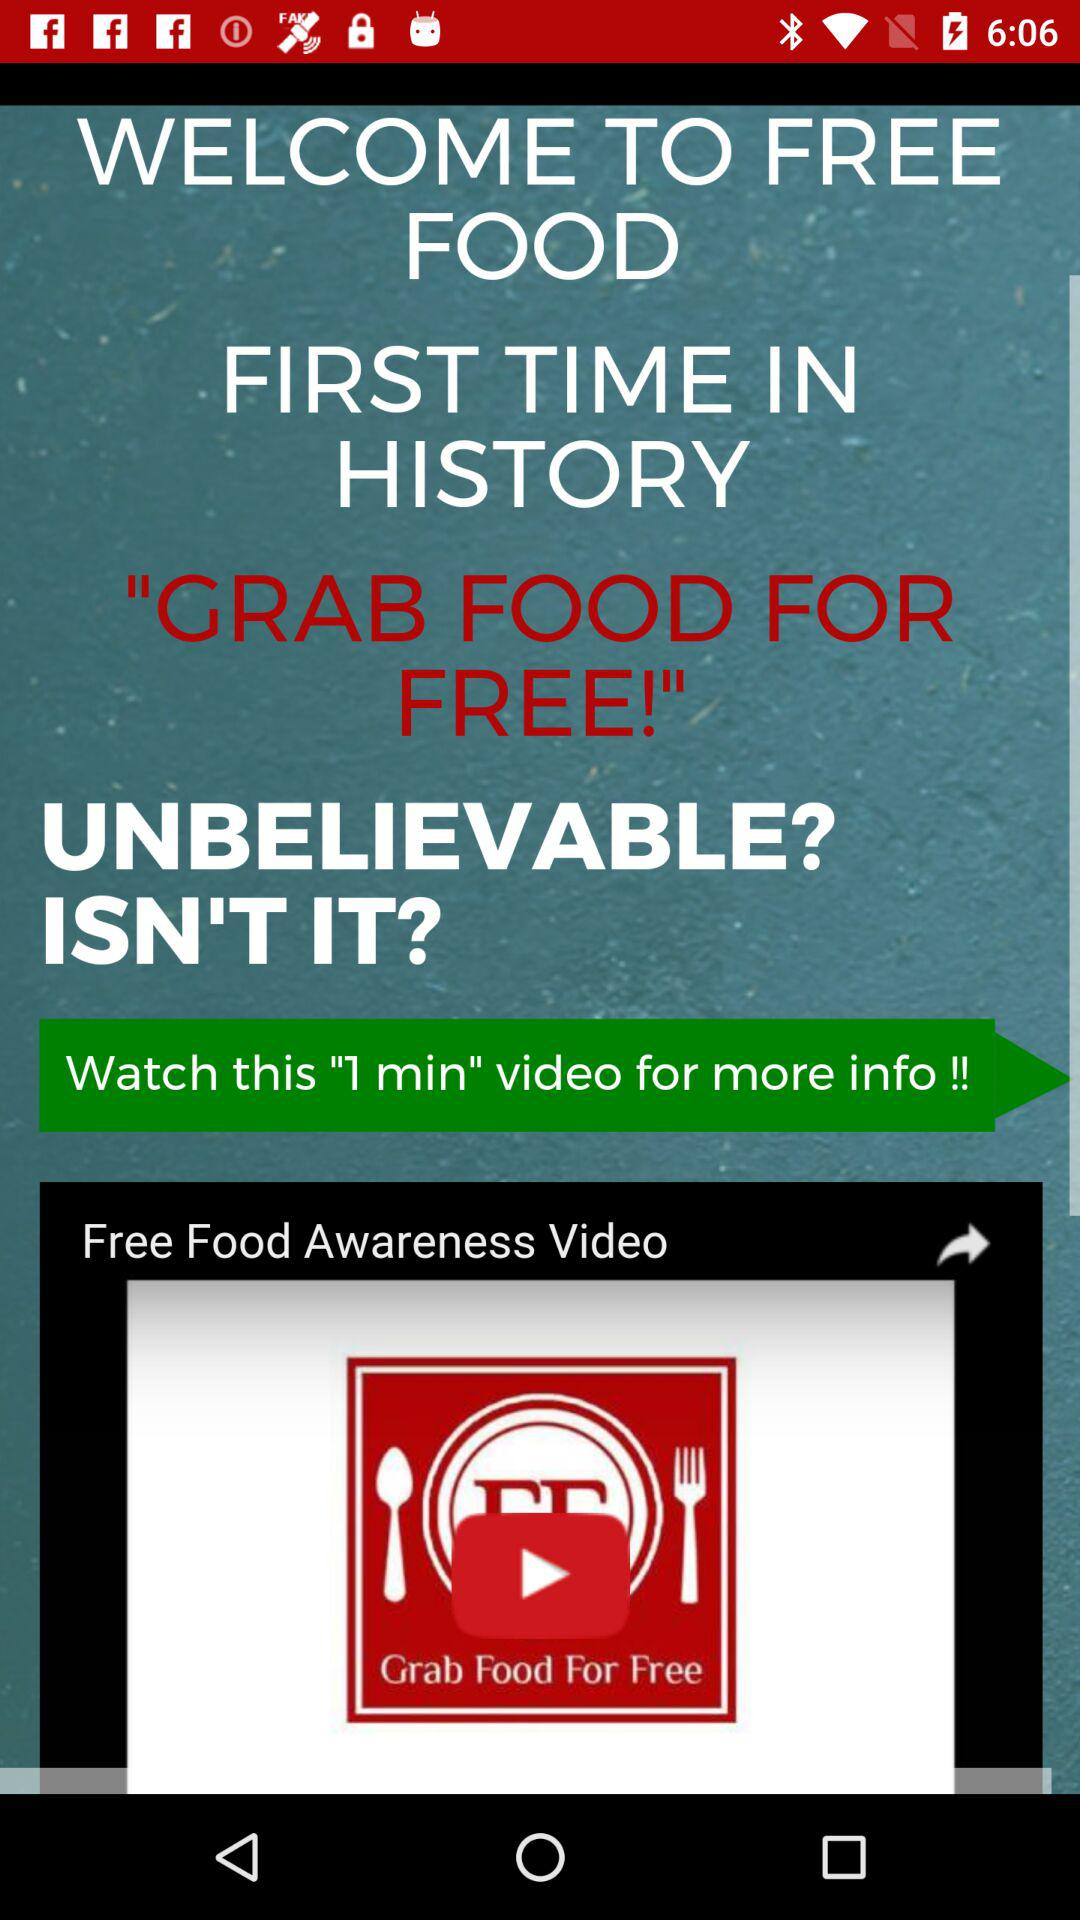What is the duration of the video? The duration of the video is 1 minute. 